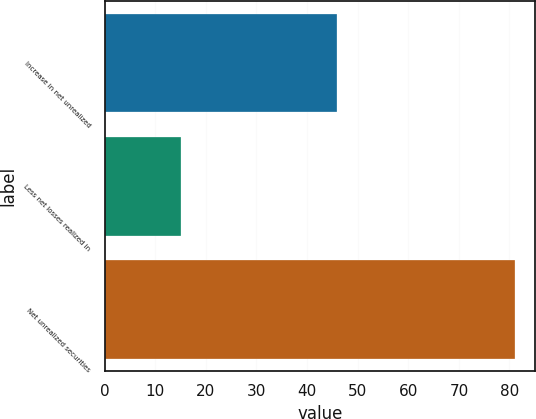Convert chart. <chart><loc_0><loc_0><loc_500><loc_500><bar_chart><fcel>Increase in net unrealized<fcel>Less net losses realized in<fcel>Net unrealized securities<nl><fcel>46<fcel>15<fcel>81<nl></chart> 